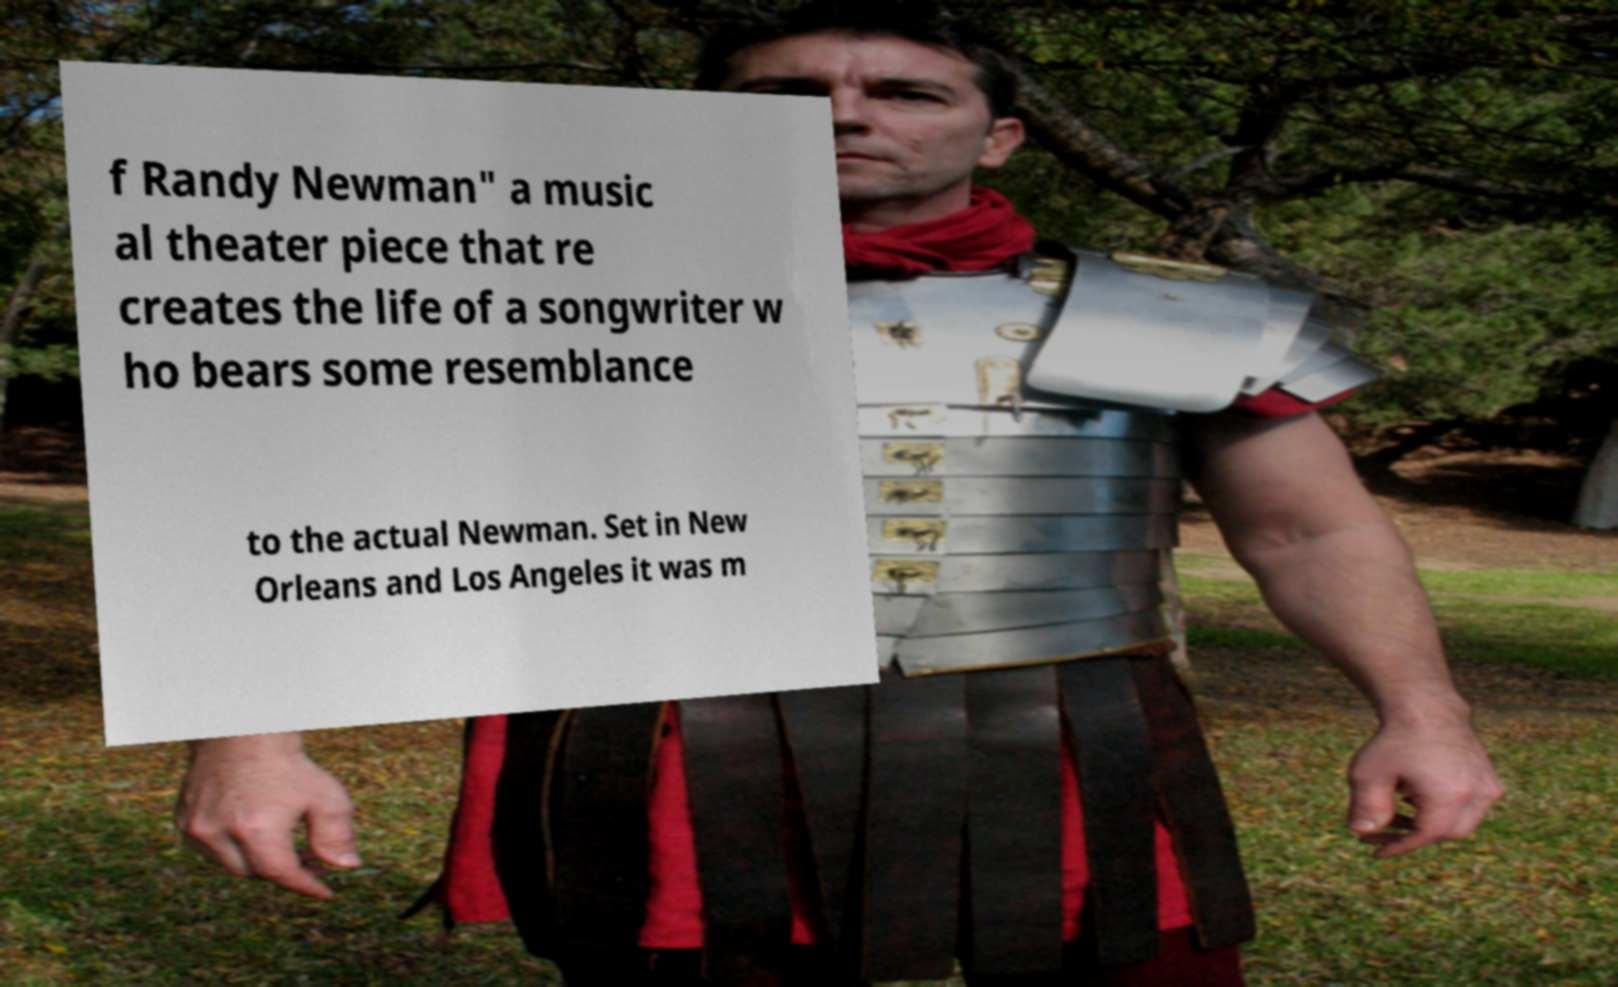Can you accurately transcribe the text from the provided image for me? f Randy Newman" a music al theater piece that re creates the life of a songwriter w ho bears some resemblance to the actual Newman. Set in New Orleans and Los Angeles it was m 